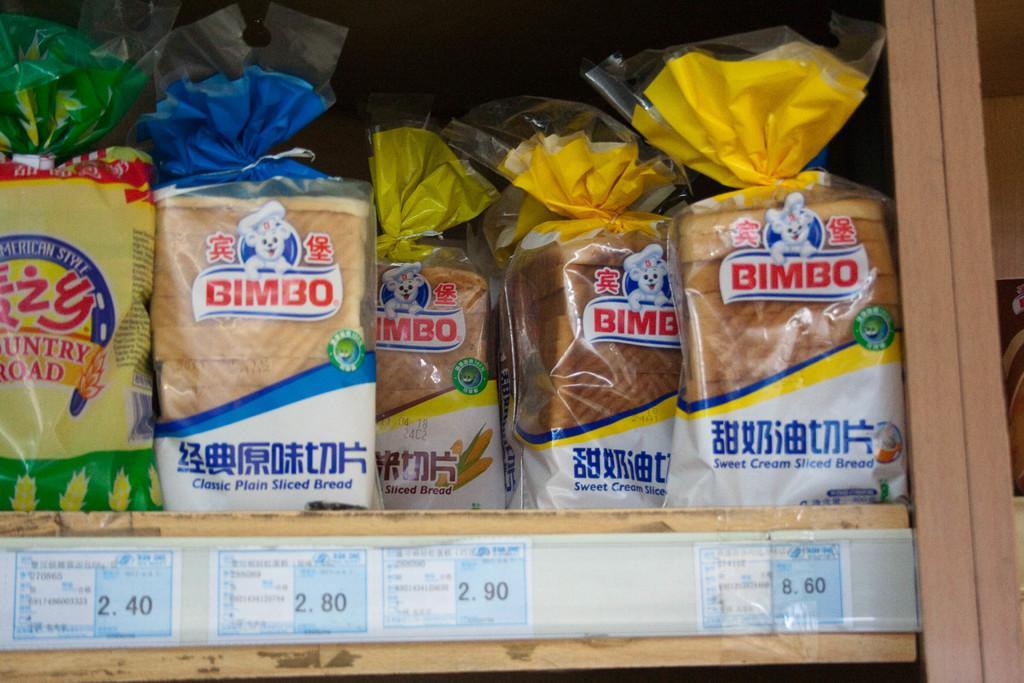Could you give a brief overview of what you see in this image? In this image, we can see bread packets in the rack and there are some posters with some text. 